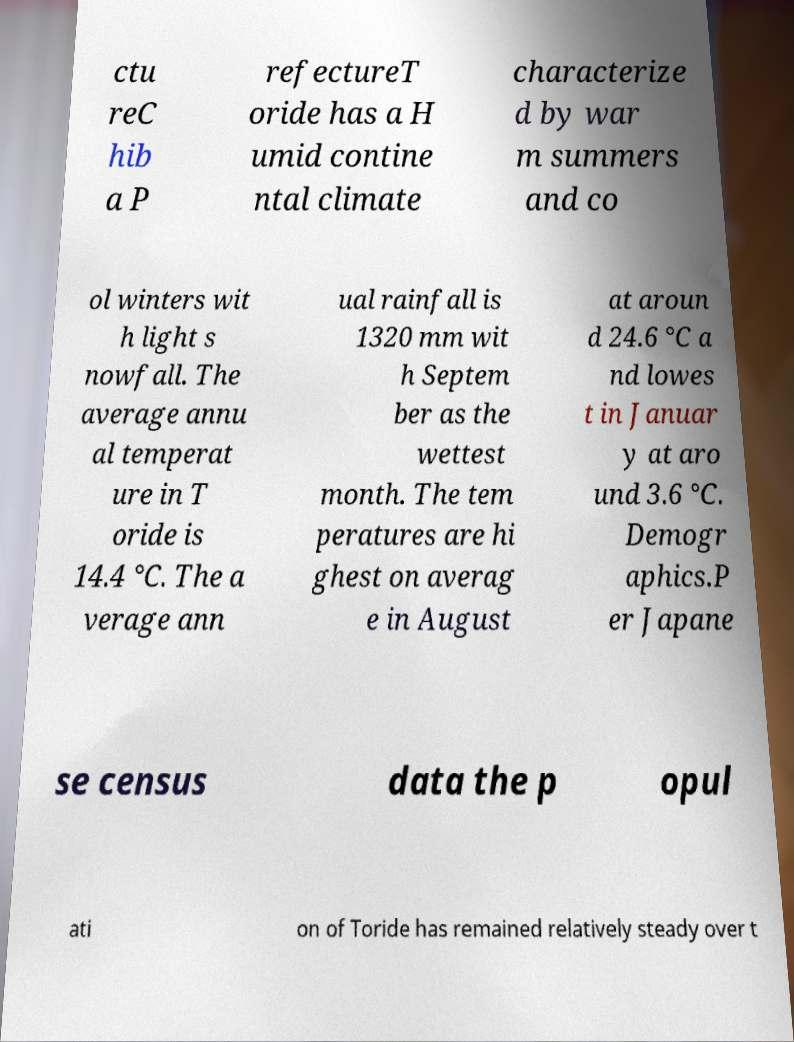For documentation purposes, I need the text within this image transcribed. Could you provide that? ctu reC hib a P refectureT oride has a H umid contine ntal climate characterize d by war m summers and co ol winters wit h light s nowfall. The average annu al temperat ure in T oride is 14.4 °C. The a verage ann ual rainfall is 1320 mm wit h Septem ber as the wettest month. The tem peratures are hi ghest on averag e in August at aroun d 24.6 °C a nd lowes t in Januar y at aro und 3.6 °C. Demogr aphics.P er Japane se census data the p opul ati on of Toride has remained relatively steady over t 